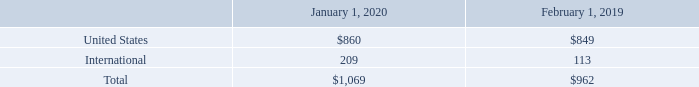Long-lived assets by geographic area, which primarily include property and equipment, net, as of the periods presented were as follows (table in millions):
No individual country other than the U.S. accounted for 10% or more of these assets as of January 31, 2020 and February 1, 2019
VMware’s product and service solutions are organized into three main product groups:
• Software-Defined Data Center
• Hybrid and Multi-Cloud Computing
• Digital Workspace—End-User Computing
VMware develops and markets product and service offerings within each of these three product groups. Additionally, synergies are leveraged across these three product areas. VMware’s products and service solutions from each of its product groups may also be bundled as part of an enterprise agreement arrangement or packaged together and sold as a suite. Accordingly, it is not practicable to determine revenue by each of the three product groups described above.
Which years does the table include information for long-lived assets by geographic area, which primarily include property and equipment, net? 2020, 2019. What was the net property and equipment in the United States in 2019?
Answer scale should be: million. 849. What was the total net property and equipment in 2020?
Answer scale should be: million. 1,069. What was the change in the international net property and equipment between 2019 and 2020?
Answer scale should be: million. 209-113
Answer: 96. What was the change in the United States net property and equipment between 2019 and 2020?
Answer scale should be: million. 860-849
Answer: 11. What was the percentage change in the total net property and equipment between 2019 and 2020?
Answer scale should be: percent. (1,069-962)/962
Answer: 11.12. 